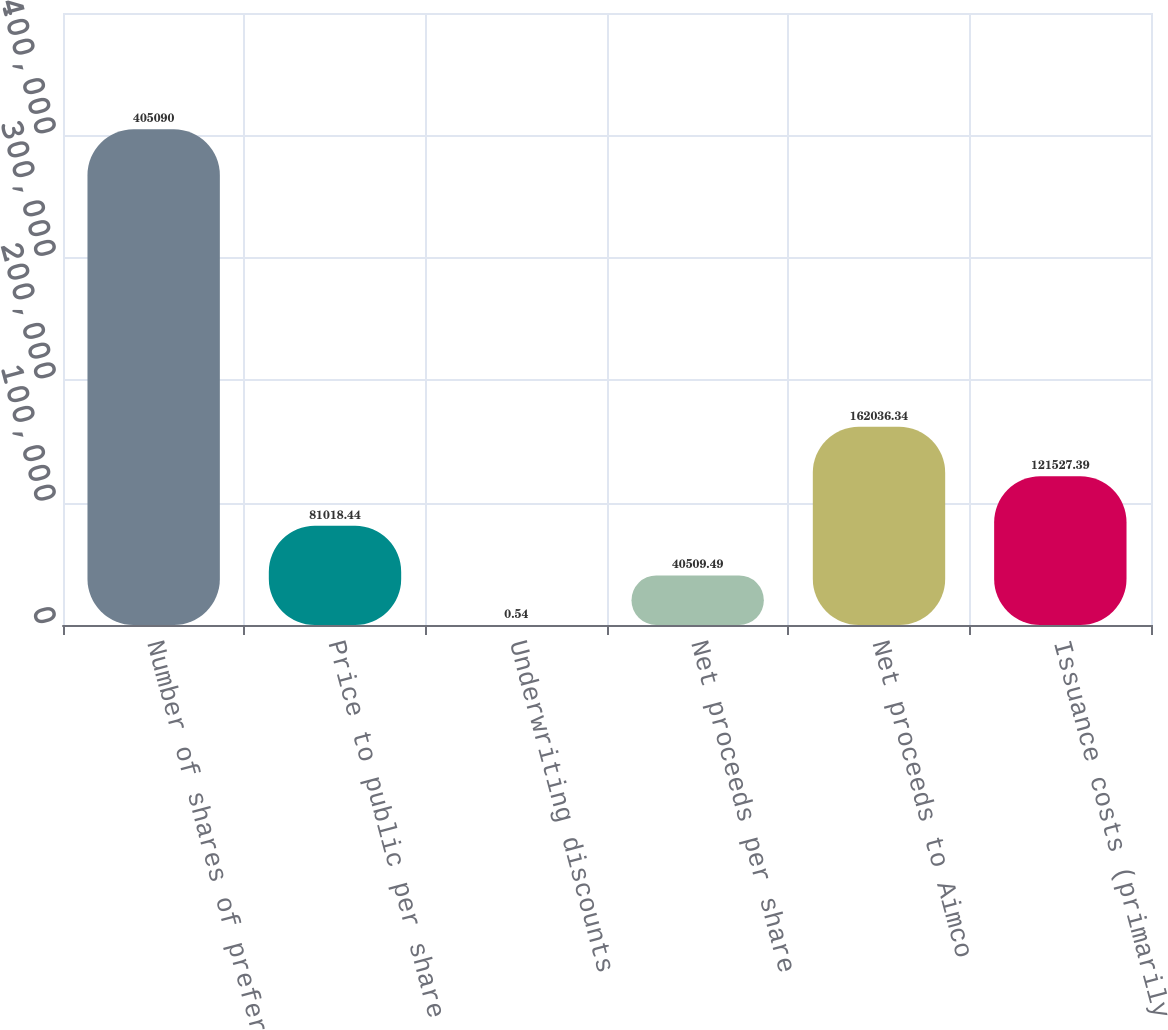Convert chart to OTSL. <chart><loc_0><loc_0><loc_500><loc_500><bar_chart><fcel>Number of shares of preferred<fcel>Price to public per share<fcel>Underwriting discounts<fcel>Net proceeds per share<fcel>Net proceeds to Aimco<fcel>Issuance costs (primarily<nl><fcel>405090<fcel>81018.4<fcel>0.54<fcel>40509.5<fcel>162036<fcel>121527<nl></chart> 